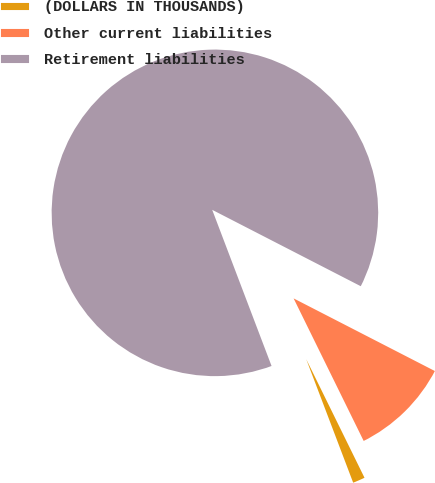Convert chart. <chart><loc_0><loc_0><loc_500><loc_500><pie_chart><fcel>(DOLLARS IN THOUSANDS)<fcel>Other current liabilities<fcel>Retirement liabilities<nl><fcel>1.49%<fcel>10.17%<fcel>88.34%<nl></chart> 